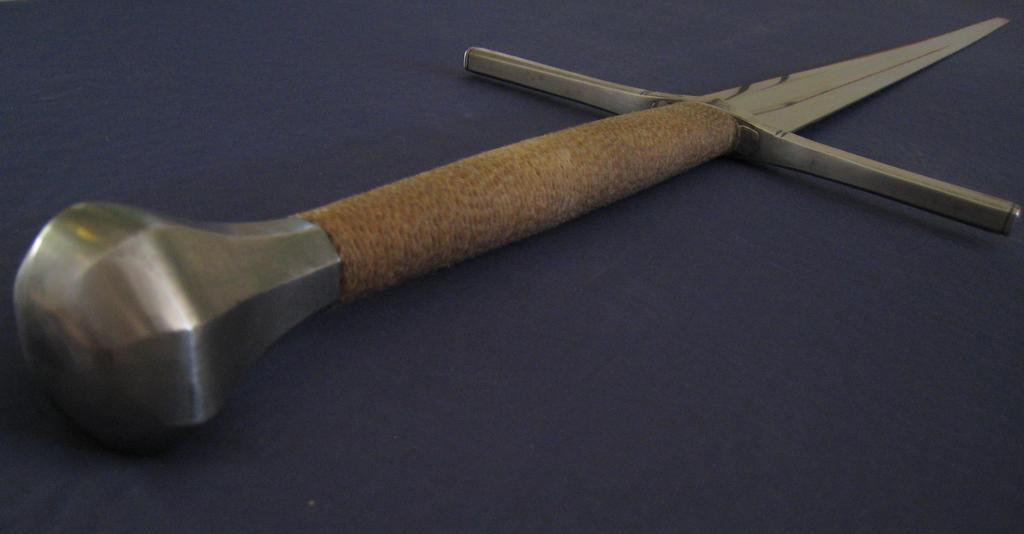What object is placed on the floor in the image? There is a sword on the floor in the image. What type of twist can be seen in the bedroom in the image? There is no twist or bedroom present in the image; it only features a sword on the floor. 